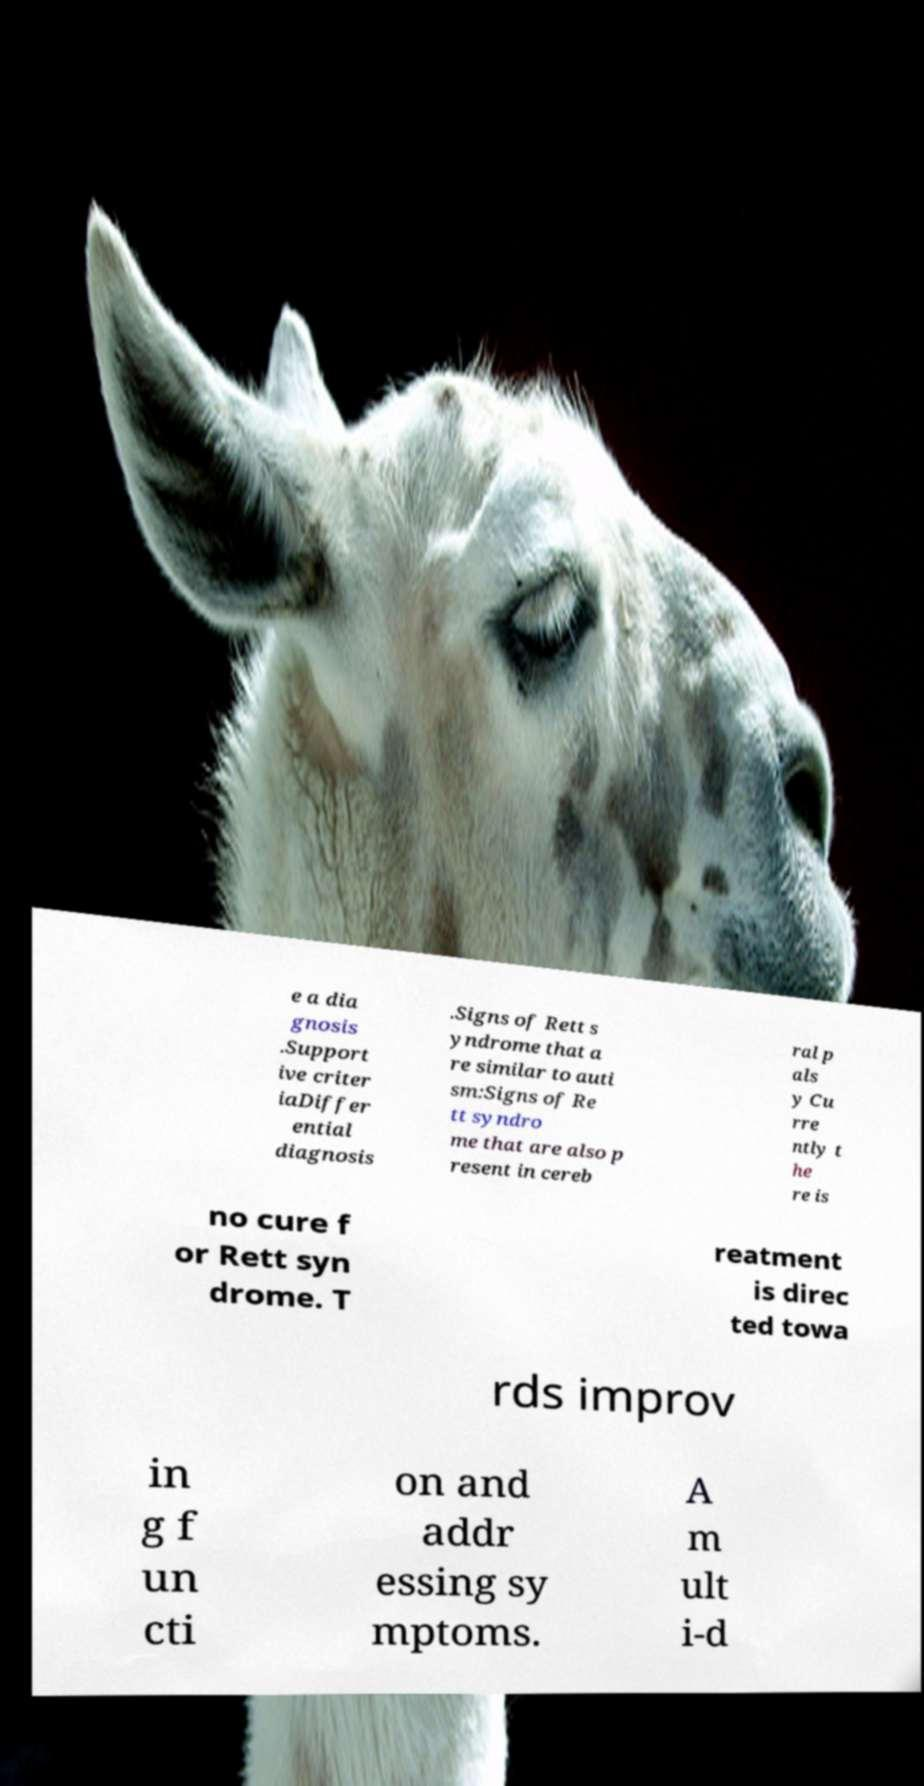Could you assist in decoding the text presented in this image and type it out clearly? e a dia gnosis .Support ive criter iaDiffer ential diagnosis .Signs of Rett s yndrome that a re similar to auti sm:Signs of Re tt syndro me that are also p resent in cereb ral p als y Cu rre ntly t he re is no cure f or Rett syn drome. T reatment is direc ted towa rds improv in g f un cti on and addr essing sy mptoms. A m ult i-d 